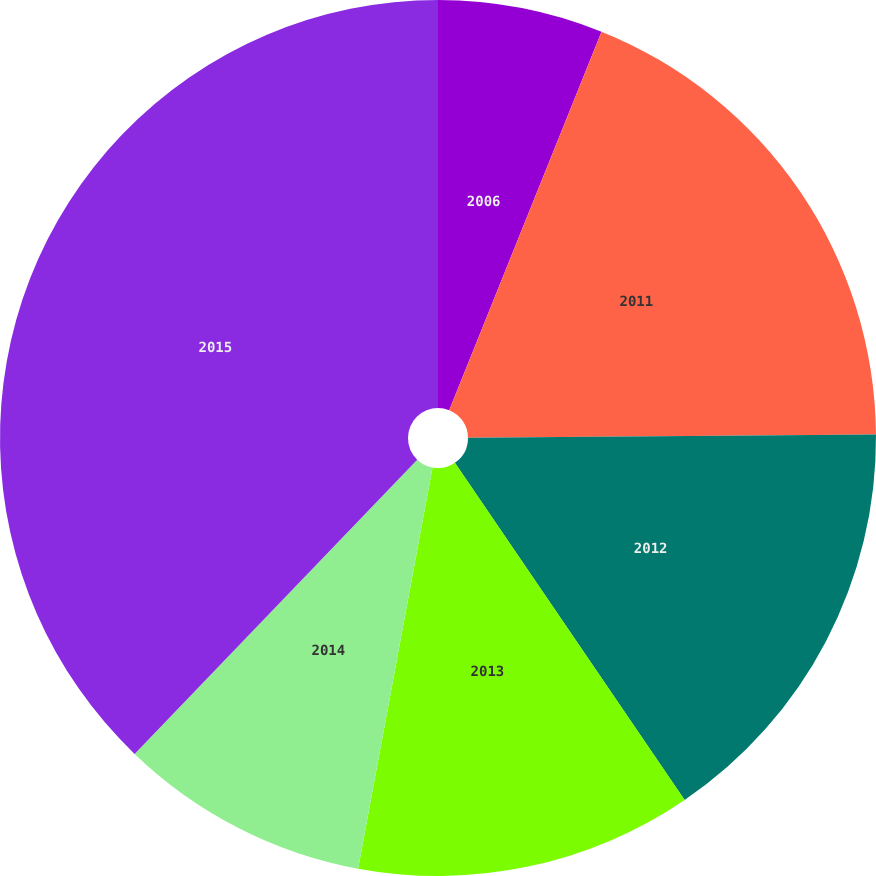Convert chart to OTSL. <chart><loc_0><loc_0><loc_500><loc_500><pie_chart><fcel>2006<fcel>2011<fcel>2012<fcel>2013<fcel>2014<fcel>2015<nl><fcel>6.09%<fcel>18.78%<fcel>15.61%<fcel>12.44%<fcel>9.26%<fcel>37.82%<nl></chart> 